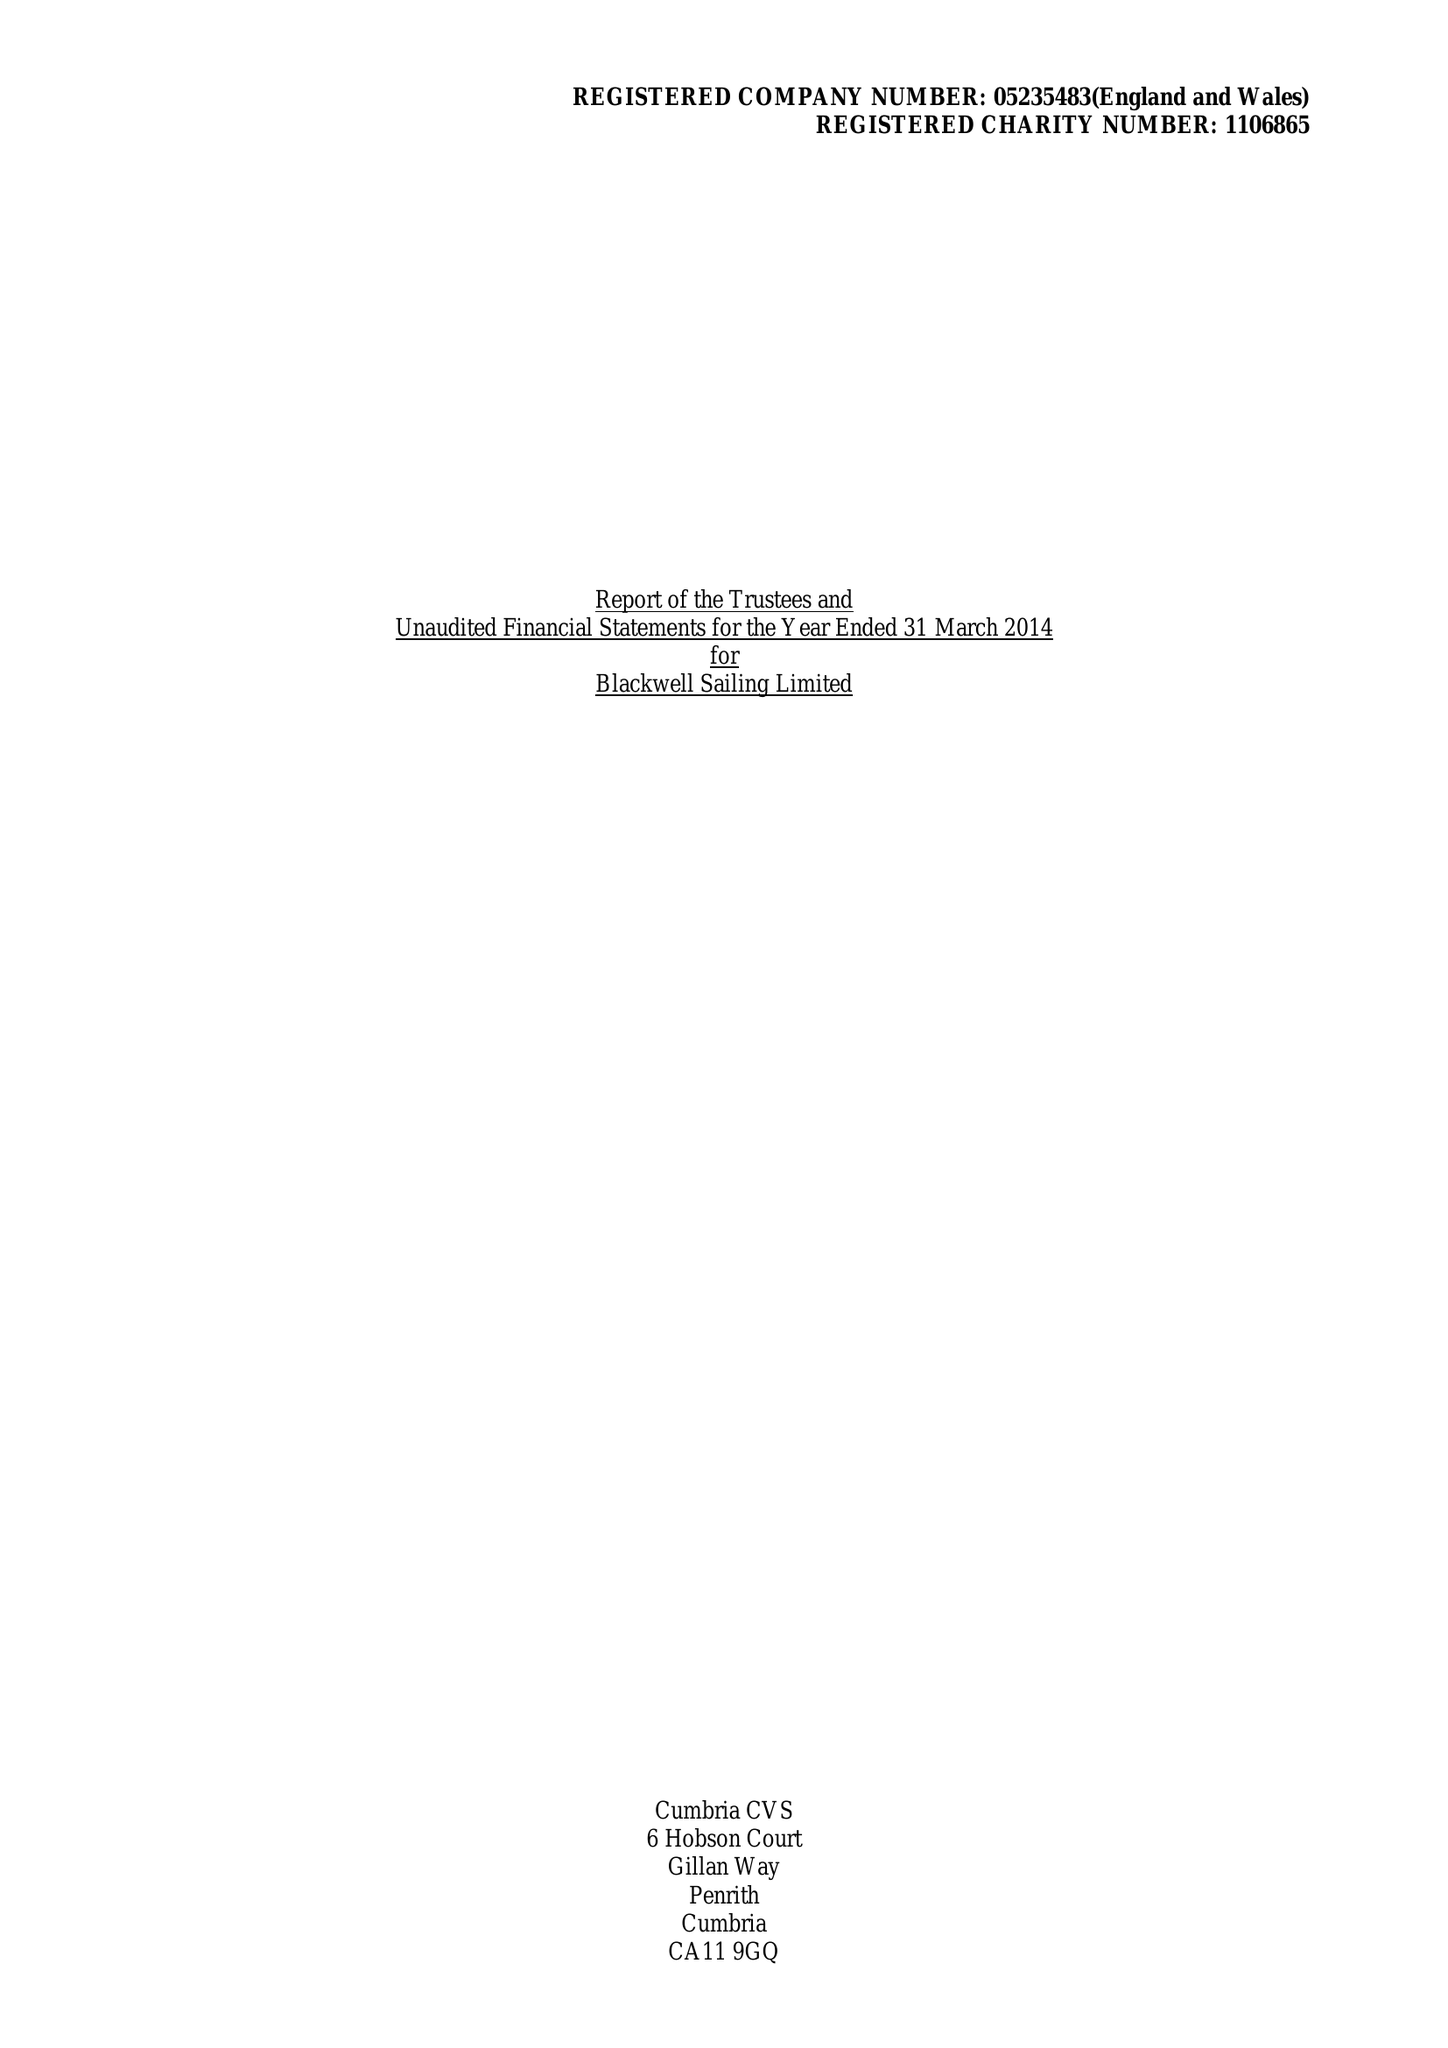What is the value for the income_annually_in_british_pounds?
Answer the question using a single word or phrase. 93085.00 